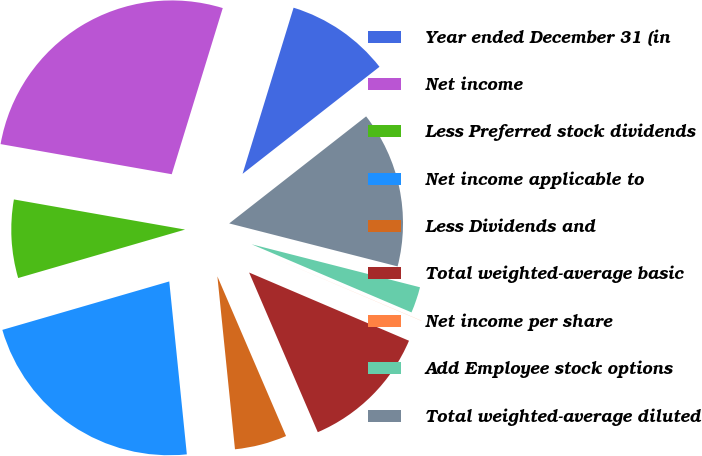Convert chart to OTSL. <chart><loc_0><loc_0><loc_500><loc_500><pie_chart><fcel>Year ended December 31 (in<fcel>Net income<fcel>Less Preferred stock dividends<fcel>Net income applicable to<fcel>Less Dividends and<fcel>Total weighted-average basic<fcel>Net income per share<fcel>Add Employee stock options<fcel>Total weighted-average diluted<nl><fcel>9.7%<fcel>26.97%<fcel>7.27%<fcel>22.12%<fcel>4.85%<fcel>12.12%<fcel>0.01%<fcel>2.43%<fcel>14.54%<nl></chart> 